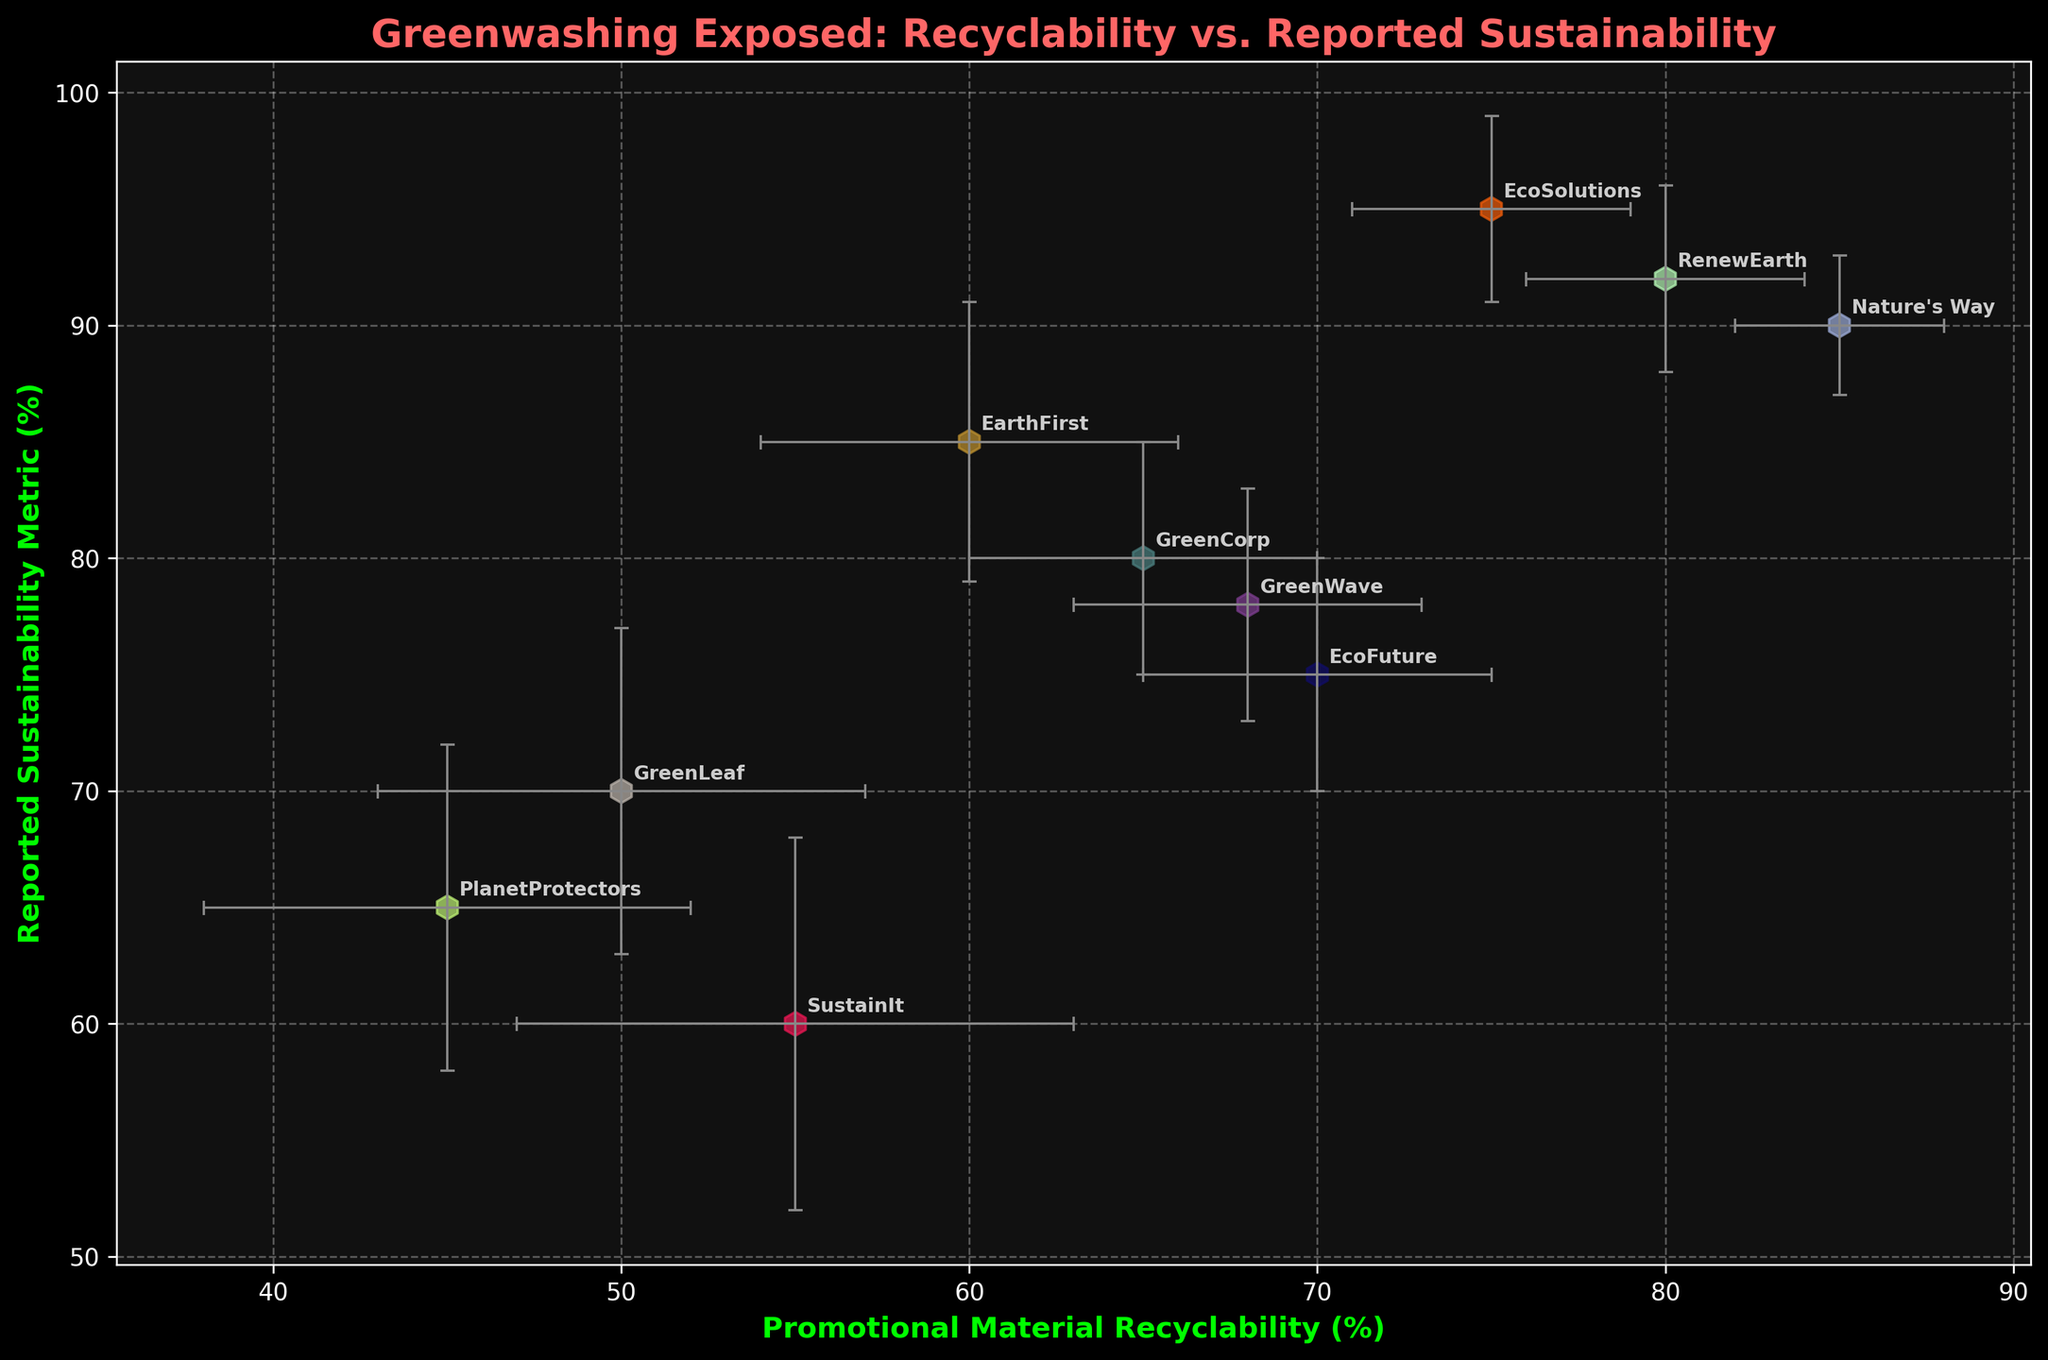what is the title of the scatter plot? The title is typically found at the top of the scatter plot and indicates what the plot is about. In this case, it's directly mentioned as part of the code used to generate the plot.
Answer: Greenwashing Exposed: Recyclability vs. Reported Sustainability what are the x-axis and y-axis labels on the scatter plot? The x-axis and y-axis labels describe what each axis represents. By looking at the plot and the code provided, we can see these.
Answer: x-axis: Promotional Material Recyclability (%), y-axis: Reported Sustainability Metric (%) how many companies are represented in the scatter plot? Each data point in the scatter plot corresponds to a company; we can count these points to determine the number of companies
Answer: 10 which company has the highest reported sustainability metric? To find the company with the highest reported sustainability metric, locate the point with the highest y-value. According to the provided data, this is **EcoSolutions** with a reported value of 95%.
Answer: EcoSolutions which company has the lowest recyclability of promotional materials? To find the company with the lowest recyclability of promotional materials, locate the point with the lowest x-value. According to the data, this is **PlanetProtectors** with a recyclability value of 45%.
Answer: PlanetProtectors how does EarthFirst compare to GreenWave in terms of both recyclability and reported sustainability metrics? Compare the x (recyclability) and y (sustainability metric) values for EarthFirst and GreenWave. EarthFirst's values are (60, 85), while GreenWave's values are (68, 78).
Answer: EarthFirst has lower recyclability but a higher reported sustainability metric than GreenWave what is the average recyclability percentage of all companies? To find the average recyclability, sum all the recyclability percentages and divide by the number of companies: (65+75+50+85+60+55+70+45+80+68) / 10.
Answer: 65.3% which company has the largest margin of error in their recyclability metric? Identify the company with the highest margin of error from the xerr values provided. The largest margin of error is **SustainIt** with a value of 8%.
Answer: SustainIt which companies have overlapping error bars in terms of recyclability? Overlapping error bars mean their range of values over their margin of error intersects. For example, check if the error bars of EcoSolutions (75±4) and RenewEarth (80±4) overlap: 71-79 and 76-84.
Answer: EcoSolutions and RenewEarth is there a general trend between recyclability and reported sustainability metrics? Look for an overall pattern in the scatter plot. Despite variations and margin of errors, if you see points roughly aligned along a line, it indicates a trend.
Answer: Slight Positive Trend 